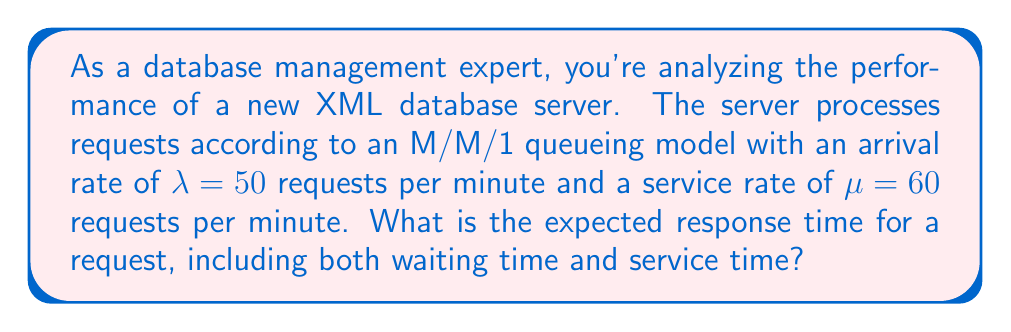Can you solve this math problem? To solve this problem, we'll use queueing theory, specifically the M/M/1 model, which is applicable to our XML database server scenario. Let's break it down step-by-step:

1) First, we need to calculate the utilization factor $\rho$:
   $$\rho = \frac{\lambda}{\mu} = \frac{50}{60} = \frac{5}{6} \approx 0.833$$

2) In an M/M/1 queue, the expected number of requests in the system (including the one being served) is given by:
   $$L = \frac{\rho}{1-\rho} = \frac{5/6}{1-5/6} = 5$$

3) Using Little's Law, we can calculate the expected time a request spends in the system (W):
   $$W = \frac{L}{\lambda}$$

4) Substituting the values:
   $$W = \frac{5}{50} = 0.1 \text{ minutes}$$

5) Convert to seconds:
   $$W = 0.1 \times 60 = 6 \text{ seconds}$$

Therefore, the expected response time for a request, including both waiting time and service time, is 6 seconds.
Answer: 6 seconds 